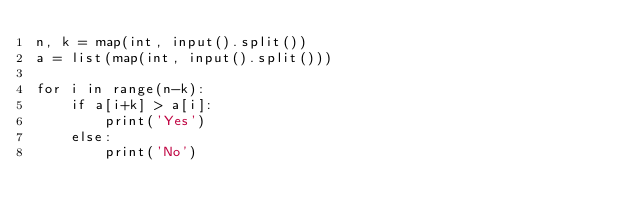<code> <loc_0><loc_0><loc_500><loc_500><_Python_>n, k = map(int, input().split())
a = list(map(int, input().split()))

for i in range(n-k):
    if a[i+k] > a[i]:
        print('Yes')
    else:
        print('No')
</code> 